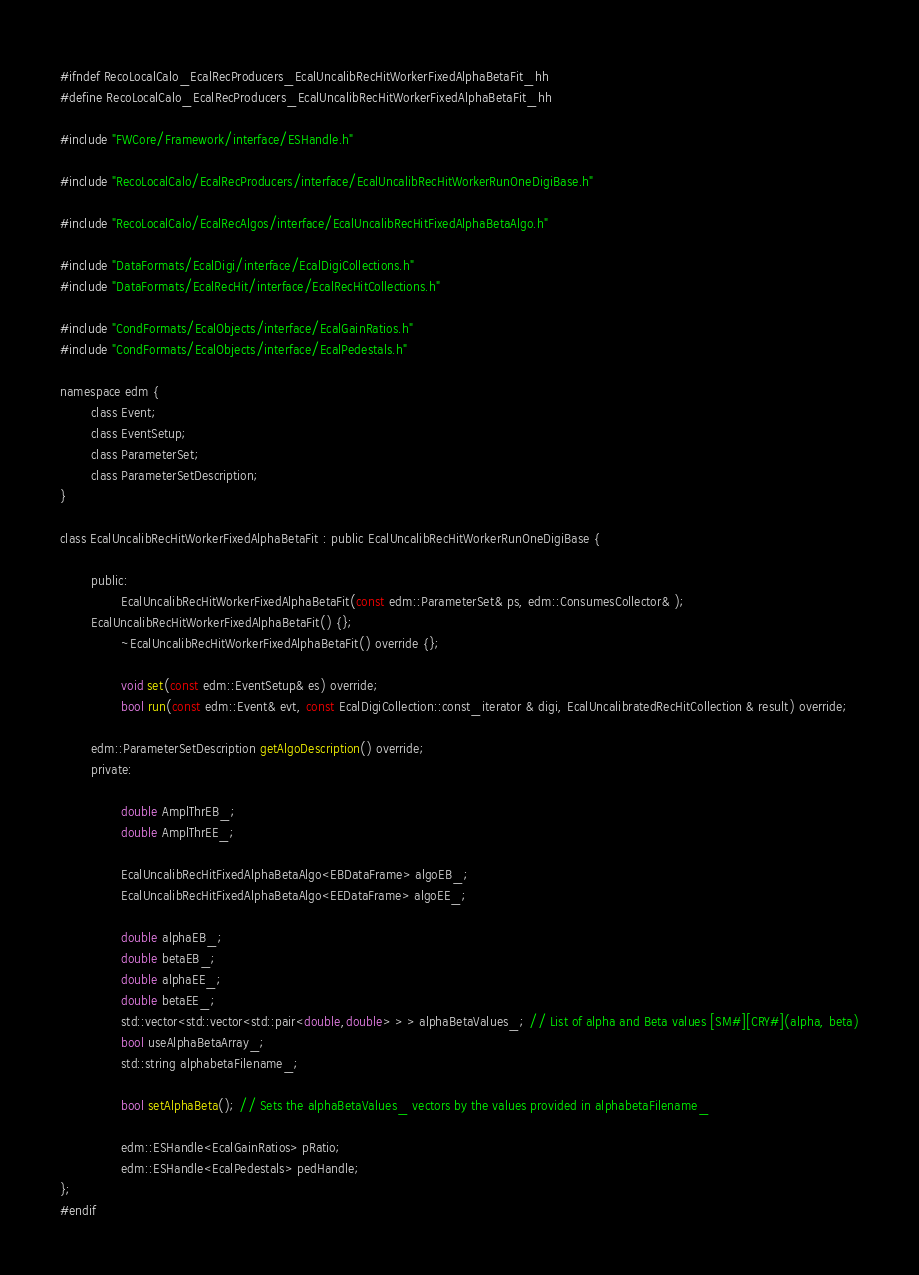<code> <loc_0><loc_0><loc_500><loc_500><_C_>#ifndef RecoLocalCalo_EcalRecProducers_EcalUncalibRecHitWorkerFixedAlphaBetaFit_hh
#define RecoLocalCalo_EcalRecProducers_EcalUncalibRecHitWorkerFixedAlphaBetaFit_hh

#include "FWCore/Framework/interface/ESHandle.h"

#include "RecoLocalCalo/EcalRecProducers/interface/EcalUncalibRecHitWorkerRunOneDigiBase.h"

#include "RecoLocalCalo/EcalRecAlgos/interface/EcalUncalibRecHitFixedAlphaBetaAlgo.h"

#include "DataFormats/EcalDigi/interface/EcalDigiCollections.h"
#include "DataFormats/EcalRecHit/interface/EcalRecHitCollections.h"

#include "CondFormats/EcalObjects/interface/EcalGainRatios.h"
#include "CondFormats/EcalObjects/interface/EcalPedestals.h"

namespace edm {
        class Event;
        class EventSetup;
        class ParameterSet;
        class ParameterSetDescription;
}

class EcalUncalibRecHitWorkerFixedAlphaBetaFit : public EcalUncalibRecHitWorkerRunOneDigiBase {

        public:
                EcalUncalibRecHitWorkerFixedAlphaBetaFit(const edm::ParameterSet& ps, edm::ConsumesCollector& ); 
		EcalUncalibRecHitWorkerFixedAlphaBetaFit() {};
                ~EcalUncalibRecHitWorkerFixedAlphaBetaFit() override {};

                void set(const edm::EventSetup& es) override;
                bool run(const edm::Event& evt, const EcalDigiCollection::const_iterator & digi, EcalUncalibratedRecHitCollection & result) override;
		
		edm::ParameterSetDescription getAlgoDescription() override;
        private:

                double AmplThrEB_;
                double AmplThrEE_;

                EcalUncalibRecHitFixedAlphaBetaAlgo<EBDataFrame> algoEB_;
                EcalUncalibRecHitFixedAlphaBetaAlgo<EEDataFrame> algoEE_;

                double alphaEB_;
                double betaEB_;
                double alphaEE_;
                double betaEE_;
                std::vector<std::vector<std::pair<double,double> > > alphaBetaValues_; // List of alpha and Beta values [SM#][CRY#](alpha, beta)
                bool useAlphaBetaArray_;
                std::string alphabetaFilename_;

                bool setAlphaBeta(); // Sets the alphaBetaValues_ vectors by the values provided in alphabetaFilename_

                edm::ESHandle<EcalGainRatios> pRatio;
                edm::ESHandle<EcalPedestals> pedHandle;
};
#endif
</code> 